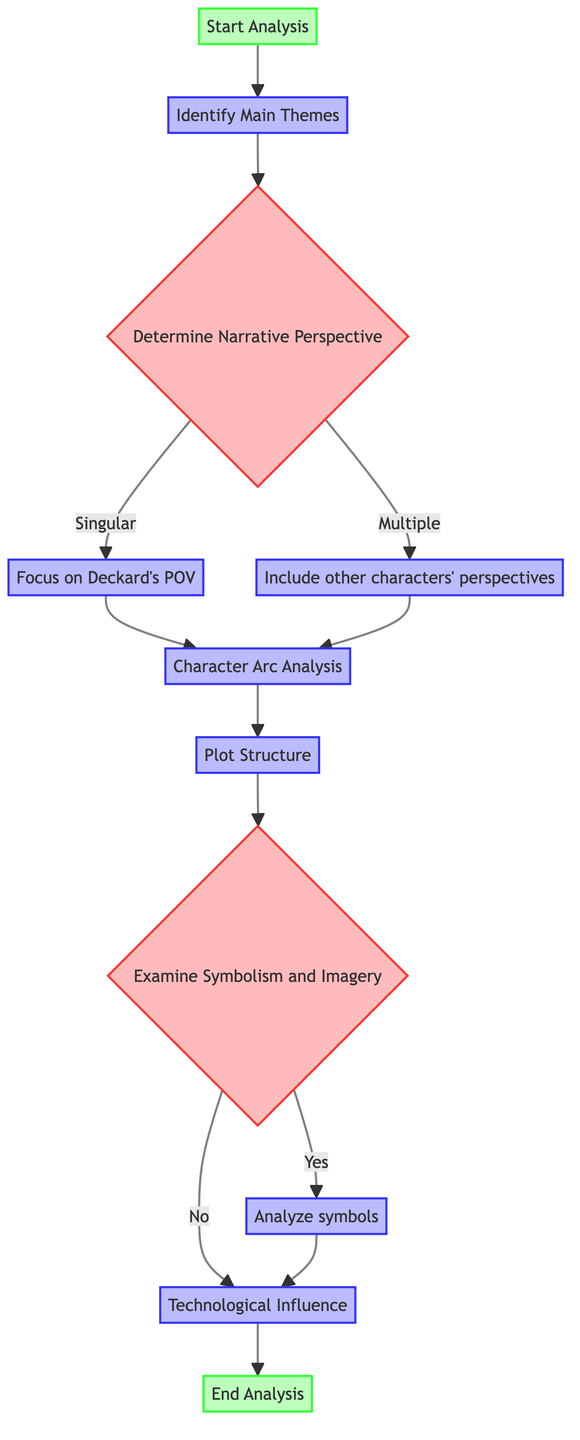What is the first step in the analysis? The first node in the flowchart, labeled "Start Analysis," indicates that the analysis begins with this step.
Answer: Start Analysis How many decision nodes are there in the flowchart? The flowchart contains two decision nodes: "Determine Narrative Perspective" and "Examine Symbolism and Imagery."
Answer: 2 What happens after "Character Arc Analysis"? After "Character Arc Analysis," the next step in the flowchart is "Plot Structure."
Answer: Plot Structure What are the symbols analyzed if symbolism is present? If symbolism is present, the flowchart specifies that the analysis includes symbols like the unicorn, eyes, and cityscape.
Answer: Unicorn, eyes, and cityscape What is the outcome if the narrative perspective is multiple? If the narrative perspective is multiple, the flowchart leads to including other characters' perspectives, which then leads to "Character Arc Analysis."
Answer: Include other characters' perspectives Which step occurs after examining symbolism and imagery if the answer is no? If the answer to "Examine Symbolism and Imagery" is no, the next step is "Technological Influence."
Answer: Technological Influence What node directly follows "Plot Structure"? The node that directly follows "Plot Structure" is "Examine Symbolism and Imagery."
Answer: Examine Symbolism and Imagery What is the final step of the analysis? The last node in the flowchart, labeled "End Analysis," indicates the conclusion of the narrative structure analysis process.
Answer: End Analysis 